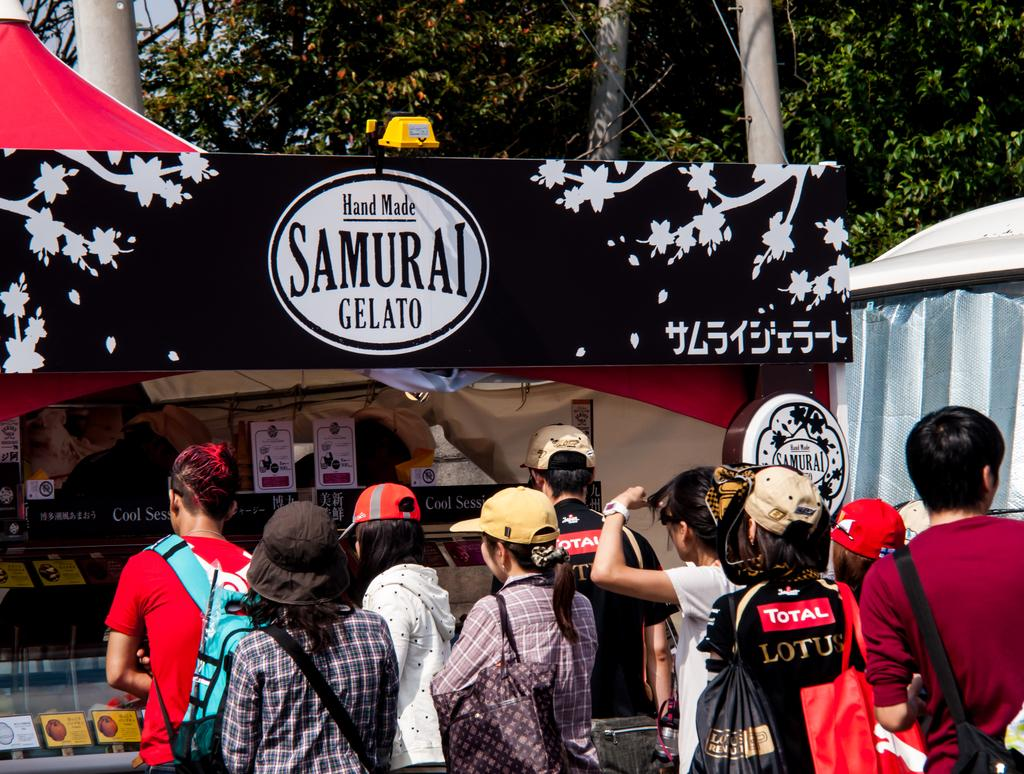What can be seen in the image involving people? There are people standing in the image. What structure is present in the image? There is a stall in the image. What is the purpose of the board in the image? The purpose of the board in the image is not specified, but it could be for displaying information or advertisements. What type of temporary shelter is in the image? There is a tent in the image. What natural elements are visible in the image? Trees are visible in the image. How does the jellyfish contribute to the atmosphere of the image? There is no jellyfish present in the image. What expertise does the expert have in the image? There is no expert present in the image. 